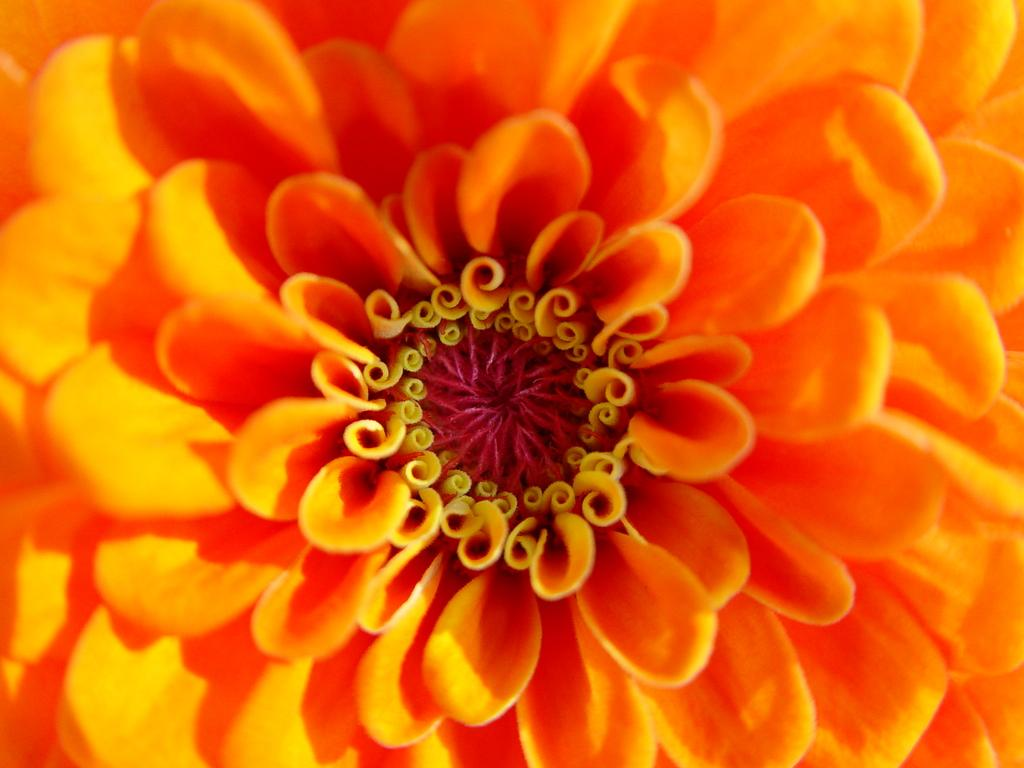What is the main subject of the image? There is a flower in the image. What type of creature is wearing a stocking while riding a railway in the image? There is no creature, stocking, or railway present in the image; it only features a flower. 